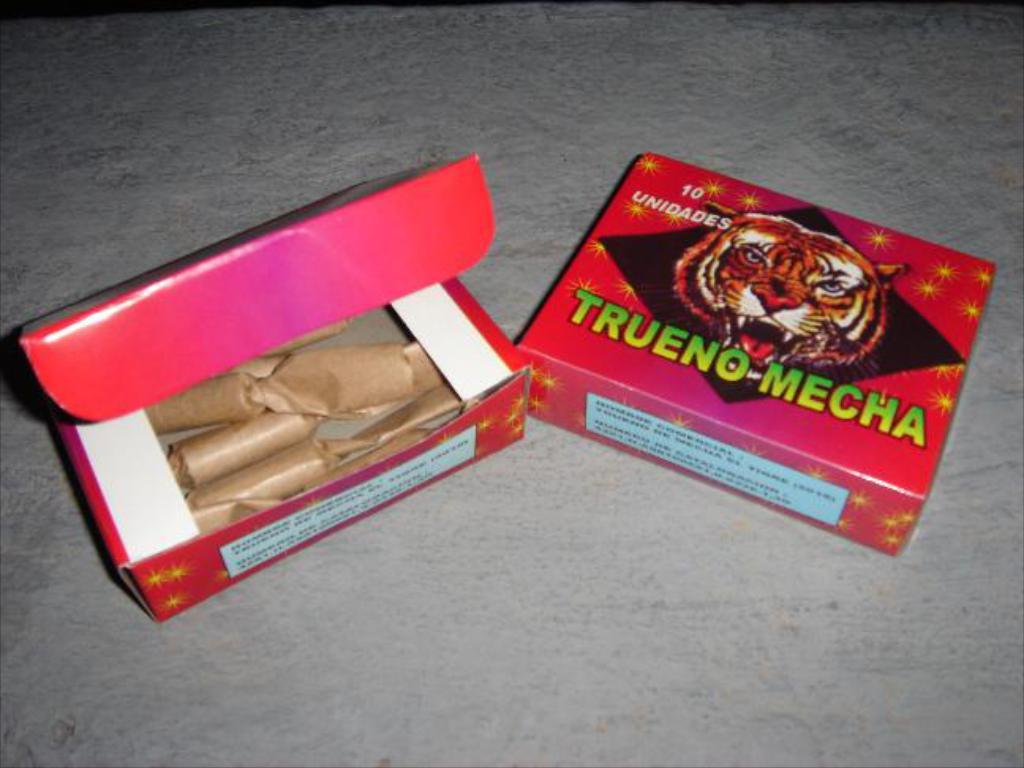<image>
Provide a brief description of the given image. Two packages of fireworks that have the following text on it saying: Trueno-Mecha. 